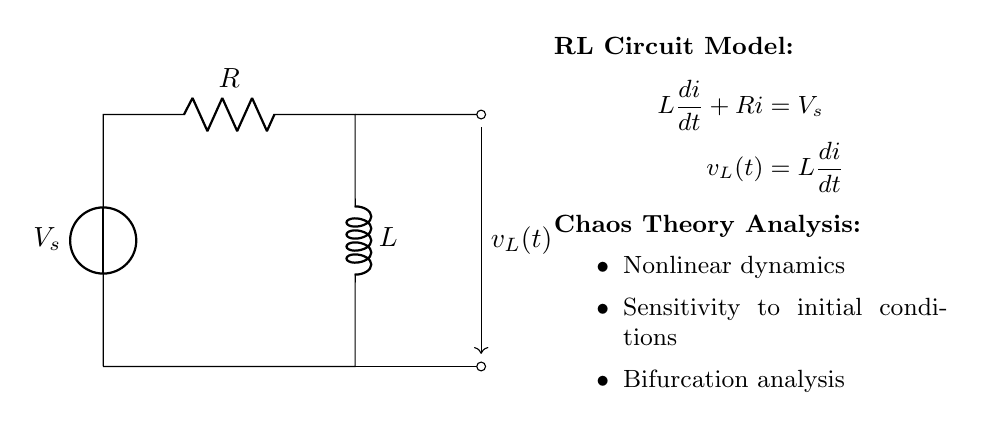What are the components in this circuit? The circuit contains a voltage source, a resistor, and an inductor. These components are clearly marked within the diagram, allowing easy identification.
Answer: voltage source, resistor, inductor What is the function of the inductor in this circuit? The inductor's primary function is to store energy in the magnetic field when current flows through it. In the context of the circuit, it responds to changes in current and contributes to the transient response of the circuit.
Answer: store energy What is the differential equation governing this RL circuit? The governing equation for the current in the circuit is derived from Kirchhoff's voltage law and is written as L(di/dt) + Ri = Vs, where Vs is the source voltage, L is the inductance, and R is the resistance.
Answer: L di/dt + Ri = Vs Explain the significance of sensitivity to initial conditions in this RL circuit. Sensitivity to initial conditions means that small changes in the initial current can lead to significantly different transient responses in the circuit. This concept relates to mathematical chaos, as it indicates that the system's future behavior is highly dependent on its starting point.
Answer: important in chaos What is the steady-state behavior of this RL circuit after a long time? After a long time, the transient responses die down, and the inductor behaves like a short circuit. The current reaches a steady-state value determined solely by the voltage source and the resistor, following Ohm's law (I = Vs/R).
Answer: short circuit What type of analysis is used to determine chaotic behavior in this RL circuit? Bifurcation analysis is typically utilized to observe how changes in system parameters (like resistance or inductance) affect the system's qualitative dynamics, which can lead to chaos. This analysis helps identify critical points where the system behavior changes dramatically.
Answer: bifurcation analysis What represents the voltage across the inductor in the circuit? The voltage across the inductor, denoted as v_L(t), is expressed mathematically as v_L(t) = L(di/dt). This expression indicates that the voltage is proportional to the rate of change of current through the inductor.
Answer: v_L(t) = L(di/dt) 